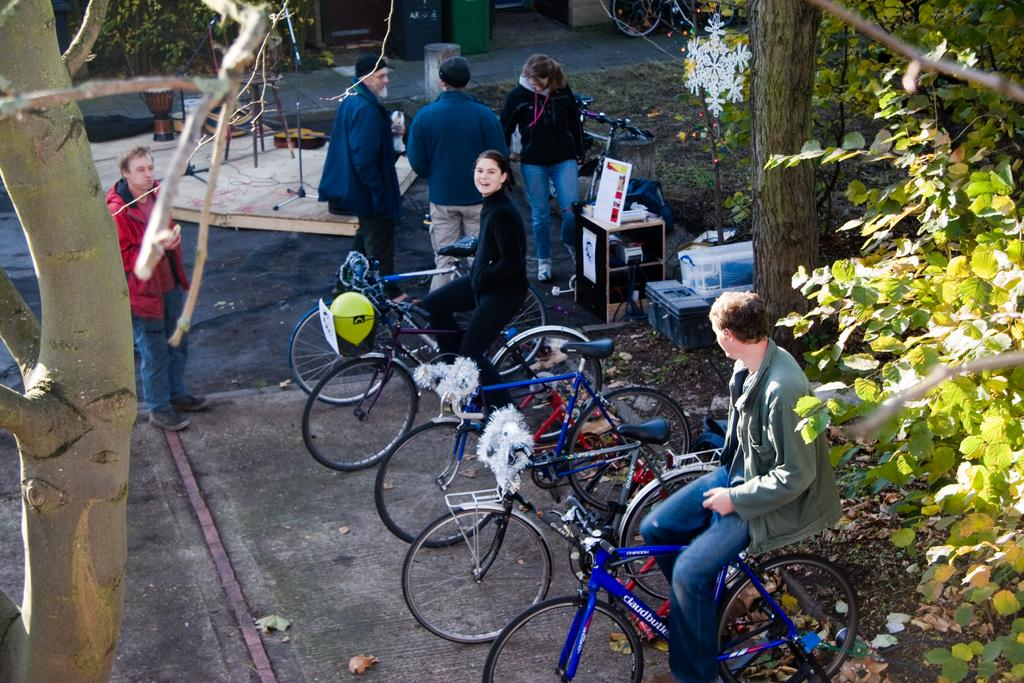What is happening in the image involving a group of people? The people are sitting on a bicycle in the image. Can you describe the people in the image besides those sitting on the bicycle? There are other people standing in the background. What can be seen in the background of the image? There is a tree visible in the background. What riddle is being solved by the people sitting on the bicycle in the image? There is no riddle being solved in the image; the people are simply sitting on a bicycle. What direction are the people sitting on the bicycle turning in the image? The image does not show the people turning; they are sitting on the bicycle. 